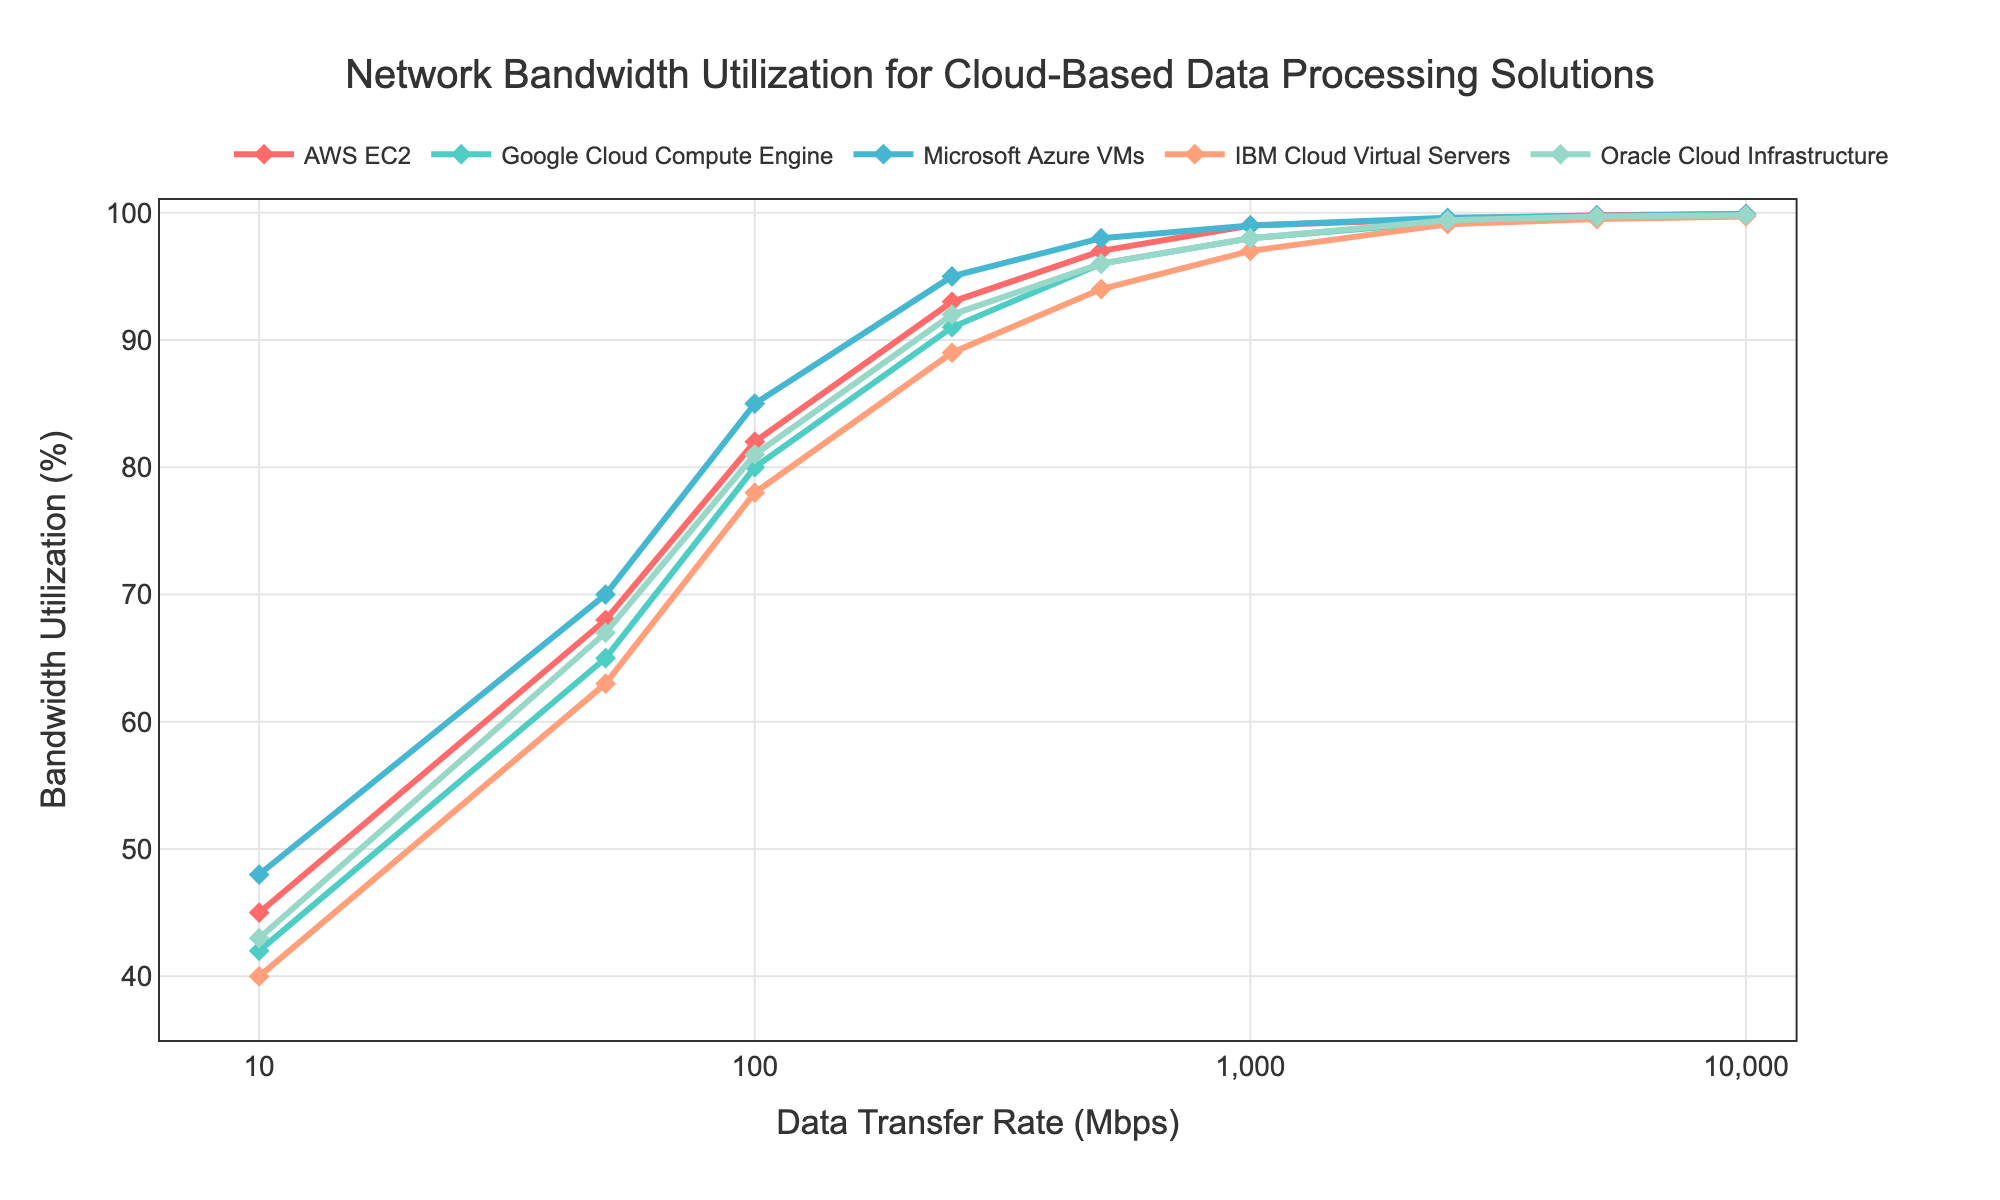What is the bandwidth utilization for AWS EC2 at a data transfer rate of 5000 Mbps? According to the chart, the bandwidth utilization for AWS EC2 at 5000 Mbps is indicated by the value where the line for AWS EC2 intersects the 5000 Mbps mark on the x-axis.
Answer: 99.8% Which cloud provider shows the highest bandwidth utilization at 1000 Mbps? Observe the points on the chart at 1000 Mbps, and identify which line is at the highest y-axis value.
Answer: AWS EC2, Microsoft Azure VMs What is the average bandwidth utilization for Oracle Cloud Infrastructure across all data transfer rates? To find the average, take the sum of the bandwidth utilization values for Oracle Cloud Infrastructure and divide by the number of data points. Sum: 43 + 67 + 81 + 92 + 96 + 98 + 99.4 + 99.7 + 99.8 = 777.9; Number of points: 9; Average: 777.9 / 9
Answer: 86.44% Which provider has the smallest increase in bandwidth utilization between 100 Mbps and 250 Mbps? Calculate the difference for each provider and determine which one is the smallest. AWS EC2: 93-82=11, Google Cloud: 91-80=11, Microsoft Azure: 95-85=10, IBM Cloud: 89-78=11, Oracle Cloud: 92-81=11
Answer: Microsoft Azure VMs Among all providers, which one reaches near-total bandwidth utilization (around 99%) the earliest on the data transfer rate scale? Identify the provider whose line first intersects the 99% bandwidth utilization mark as you move from left to right along the x-axis (data transfer rate).
Answer: AWS EC2, Microsoft Azure VMs How does the bandwidth utilization of Google Cloud compare to IBM Cloud at 2500 Mbps? Check the y-values for Google Cloud and IBM Cloud at the 2500 Mbps point, then compare them. Google Cloud: 99.3%, IBM Cloud: 99.1%
Answer: Google Cloud has slightly higher utilization Across all data transfer rates, which provider has the most consistent bandwidth utilization, i.e., the smallest variance? Calculate the variance of bandwidth utilization values for each provider to determine which is the smallest. Variance calculation involves finding the average of the squared differences from the mean.
Answer: IBM Cloud Virtual Servers What is the difference in bandwidth utilization between the highest and lowest providers at 10 Mbps? Identify the highest and lowest y-values at 10 Mbps and subtract the lowest from the highest. Highest: Microsoft Azure (48%), Lowest: IBM Cloud (40%); Difference: 48 - 40
Answer: 8% Which data transfer rate shows the widest range of bandwidth utilization across different providers? For each data transfer rate, find the range by subtracting the lowest utilization value from the highest, and then identify the transfer rate with the largest range.
Answer: 10 Mbps (range: 48 - 40 = 8%) What trend do you observe in the bandwidth utilization as the data transfer rate increases, particularly at 5000 Mbps and above? Examine the lines for each provider at and beyond 5000 Mbps to describe their behavior.
Answer: All providers plateau near or reach 99% utilization 